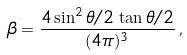<formula> <loc_0><loc_0><loc_500><loc_500>\beta = { \frac { 4 \sin ^ { 2 } \theta / 2 \, \tan \theta / 2 } { ( 4 \pi ) ^ { 3 } } } \, ,</formula> 